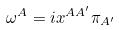<formula> <loc_0><loc_0><loc_500><loc_500>\omega ^ { A } = i x ^ { A A ^ { \prime } } \pi _ { A ^ { \prime } }</formula> 